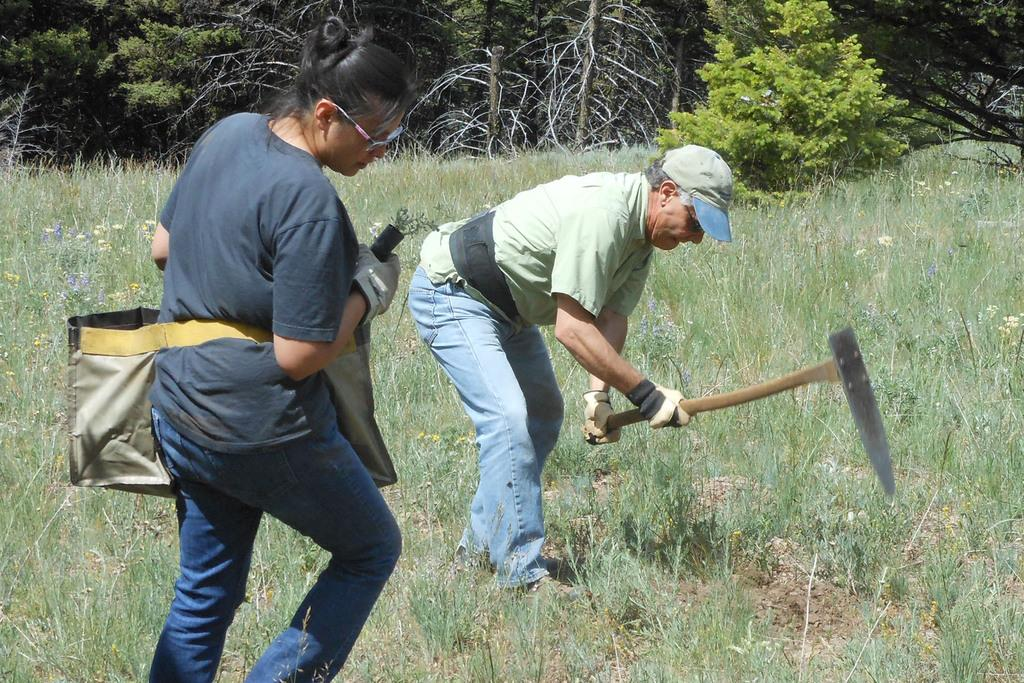How many people are in the image? There are two persons in the image. What is the setting of the image? The persons are standing on the grass. What are the persons holding in the image? The persons are holding objects. What can be seen in the background of the image? There are trees visible in the background of the image. What grade did the person in the image receive for their performance? There is no indication of a performance or grade in the image; it simply shows two persons standing on the grass and holding objects. How many fingers can be seen on the person's hand in the image? The image does not show any fingers or hands; it only shows two persons standing on the grass and holding objects. 